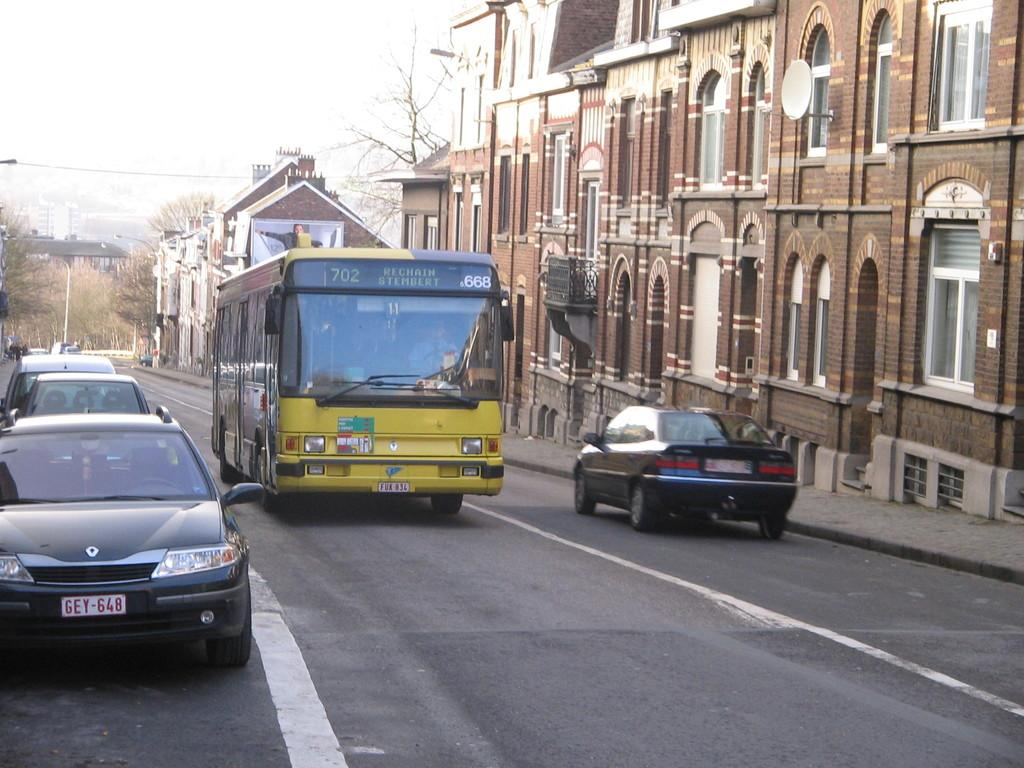<image>
Write a terse but informative summary of the picture. A city bus headed for Rechain Stembert. has number 11 on it. 